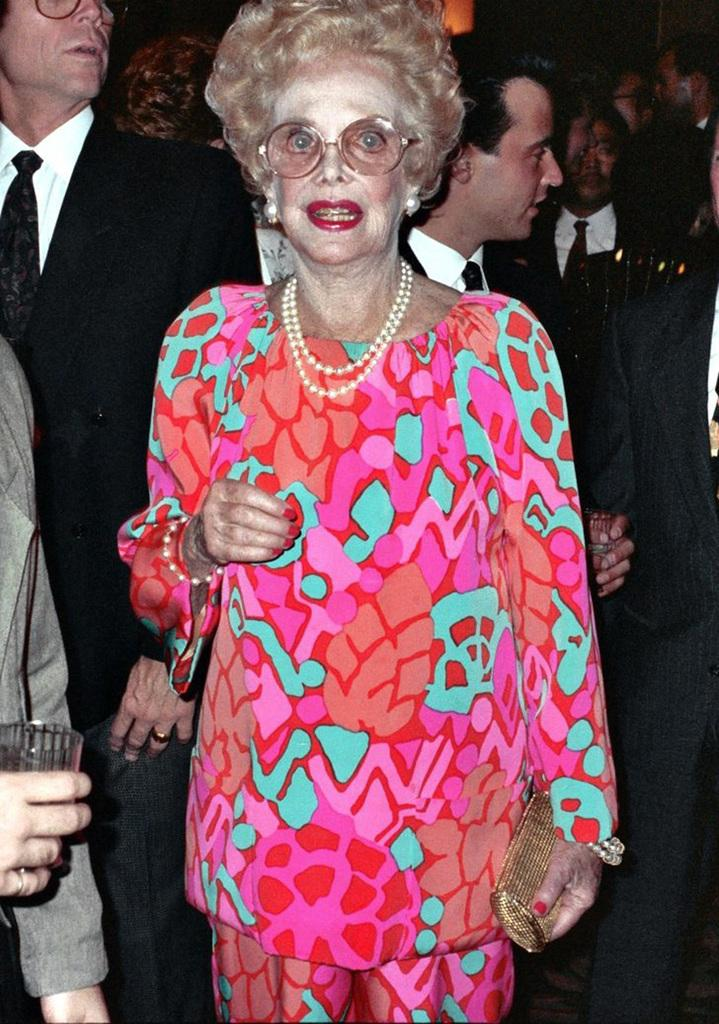What can be observed about the people in the image? There are people standing in the image. What is the woman holding in the image? A woman is holding a purse. What is the man holding in the image? A man is holding a glass. What type of music is being played in the image? There is no indication of music being played in the image. What is the cause of the man's glass being half-full in the image? The image does not provide any information about the cause of the man's glass being half-full. 